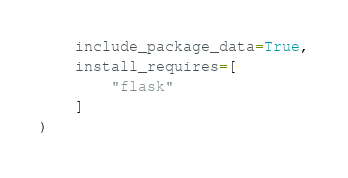Convert code to text. <code><loc_0><loc_0><loc_500><loc_500><_Python_>    include_package_data=True,
    install_requires=[
        "flask"
    ]
)</code> 